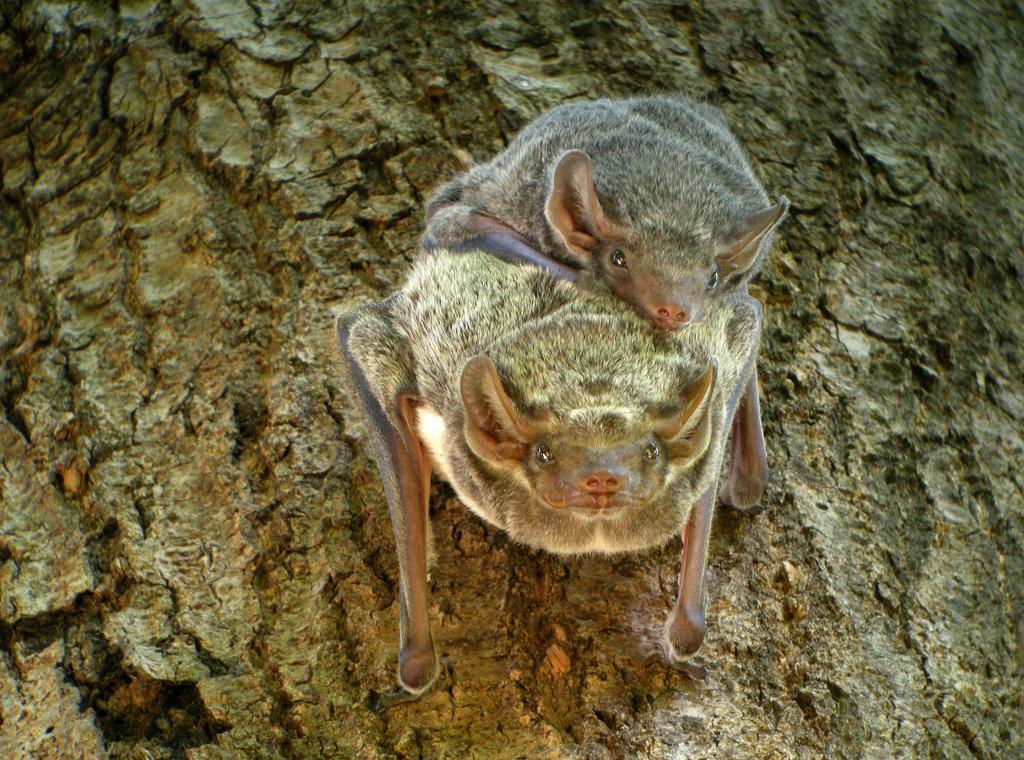Could you give a brief overview of what you see in this image? In this image, we can see two naked rumped tomb bats are on the surface. 